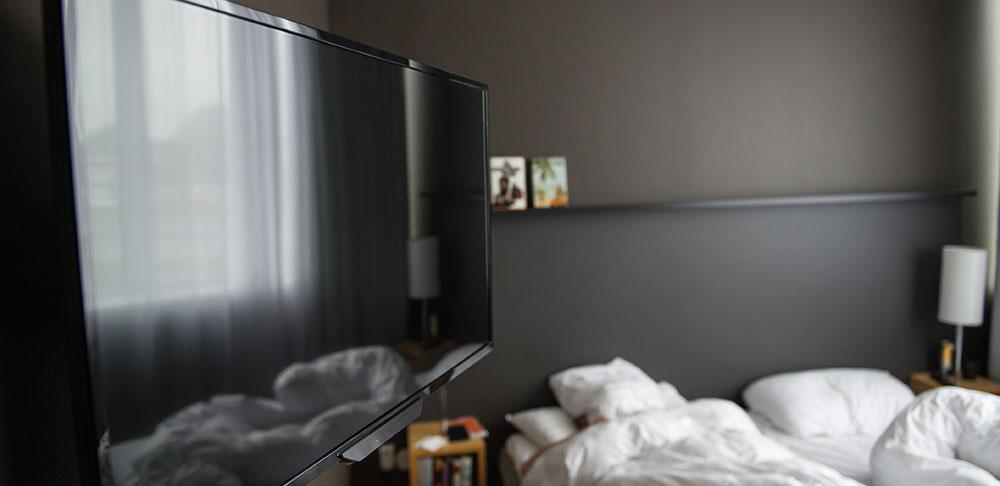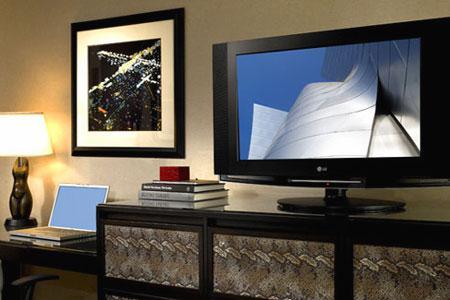The first image is the image on the left, the second image is the image on the right. For the images shown, is this caption "There is a yellowish lamp turned on near a wall." true? Answer yes or no. Yes. 